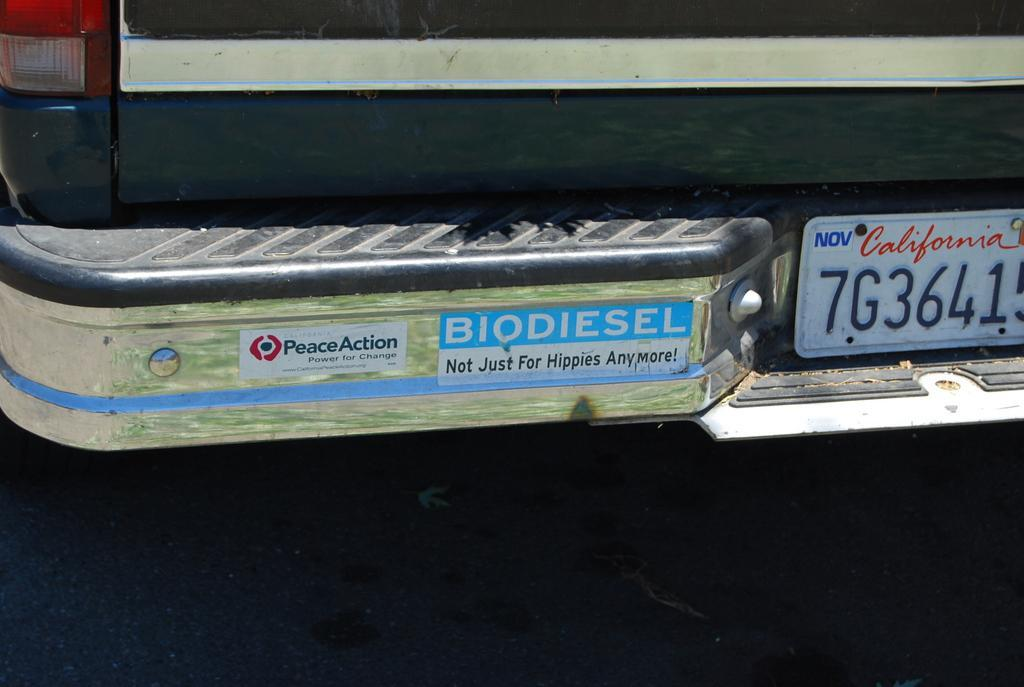<image>
Describe the image concisely. A truck with a California license plate says Biodiesel on a bumper sticker. 